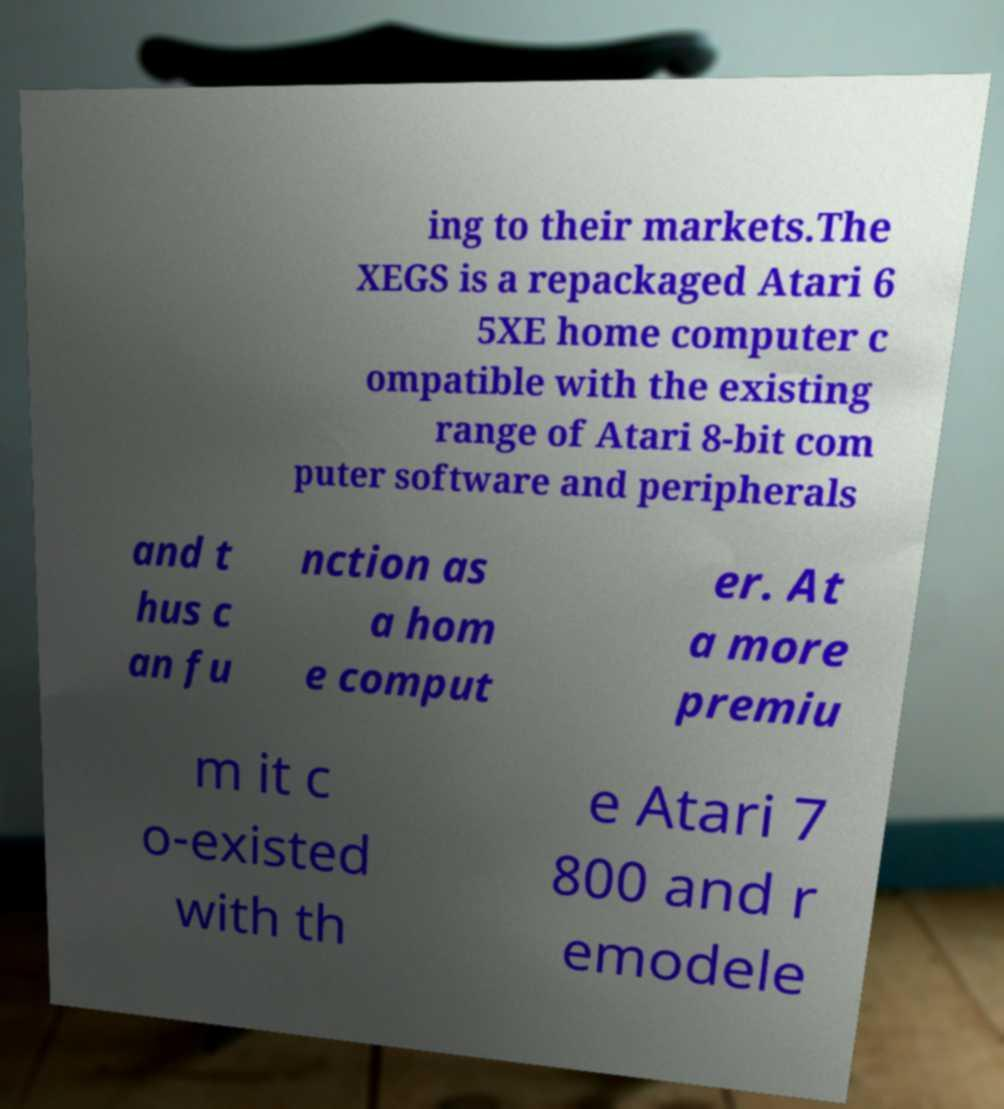Please identify and transcribe the text found in this image. ing to their markets.The XEGS is a repackaged Atari 6 5XE home computer c ompatible with the existing range of Atari 8-bit com puter software and peripherals and t hus c an fu nction as a hom e comput er. At a more premiu m it c o-existed with th e Atari 7 800 and r emodele 